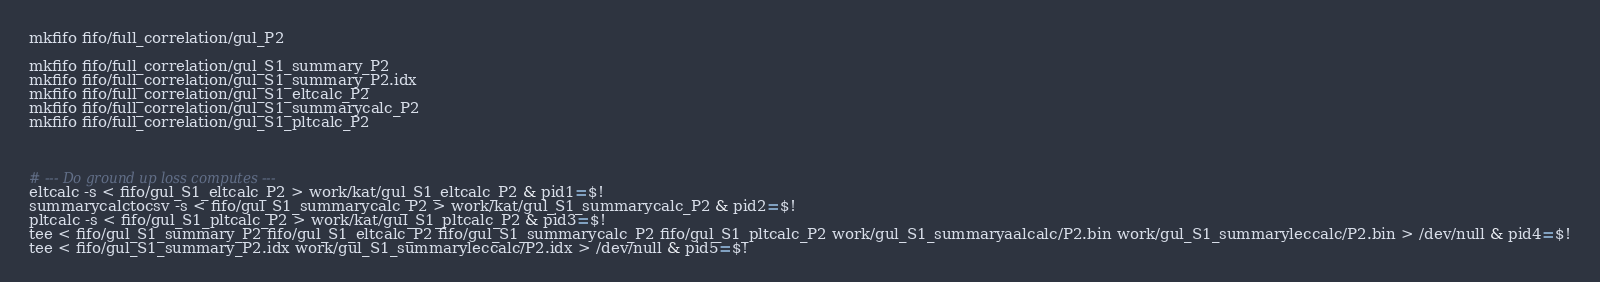<code> <loc_0><loc_0><loc_500><loc_500><_Bash_>mkfifo fifo/full_correlation/gul_P2

mkfifo fifo/full_correlation/gul_S1_summary_P2
mkfifo fifo/full_correlation/gul_S1_summary_P2.idx
mkfifo fifo/full_correlation/gul_S1_eltcalc_P2
mkfifo fifo/full_correlation/gul_S1_summarycalc_P2
mkfifo fifo/full_correlation/gul_S1_pltcalc_P2



# --- Do ground up loss computes ---
eltcalc -s < fifo/gul_S1_eltcalc_P2 > work/kat/gul_S1_eltcalc_P2 & pid1=$!
summarycalctocsv -s < fifo/gul_S1_summarycalc_P2 > work/kat/gul_S1_summarycalc_P2 & pid2=$!
pltcalc -s < fifo/gul_S1_pltcalc_P2 > work/kat/gul_S1_pltcalc_P2 & pid3=$!
tee < fifo/gul_S1_summary_P2 fifo/gul_S1_eltcalc_P2 fifo/gul_S1_summarycalc_P2 fifo/gul_S1_pltcalc_P2 work/gul_S1_summaryaalcalc/P2.bin work/gul_S1_summaryleccalc/P2.bin > /dev/null & pid4=$!
tee < fifo/gul_S1_summary_P2.idx work/gul_S1_summaryleccalc/P2.idx > /dev/null & pid5=$!</code> 